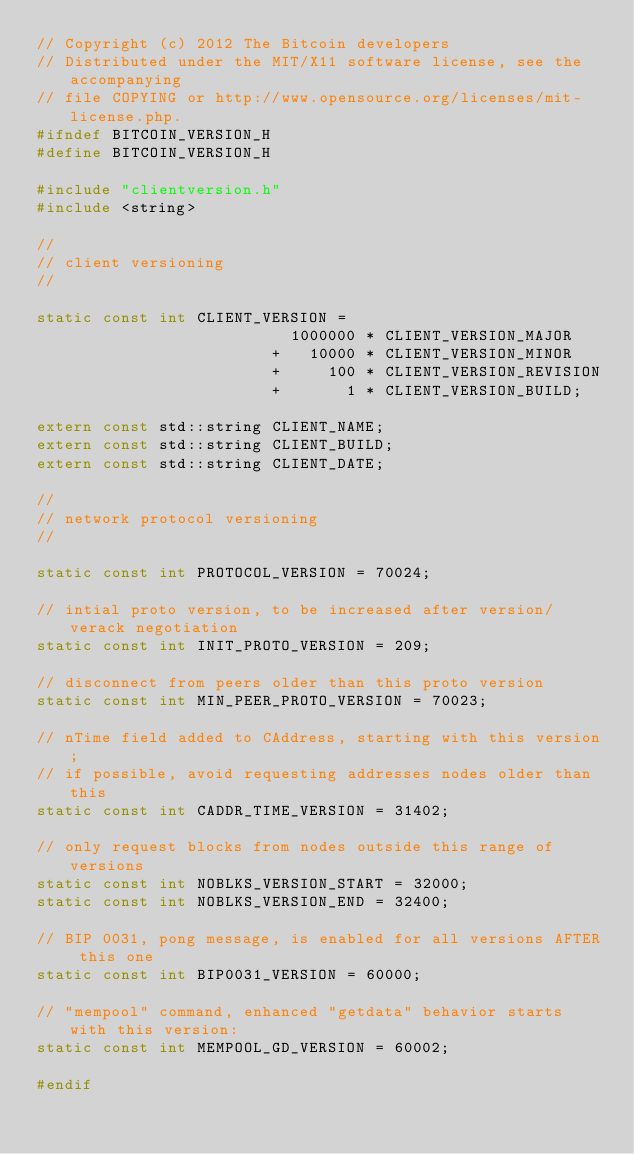Convert code to text. <code><loc_0><loc_0><loc_500><loc_500><_C_>// Copyright (c) 2012 The Bitcoin developers
// Distributed under the MIT/X11 software license, see the accompanying
// file COPYING or http://www.opensource.org/licenses/mit-license.php.
#ifndef BITCOIN_VERSION_H
#define BITCOIN_VERSION_H

#include "clientversion.h"
#include <string>

//
// client versioning
//

static const int CLIENT_VERSION =
                           1000000 * CLIENT_VERSION_MAJOR
                         +   10000 * CLIENT_VERSION_MINOR
                         +     100 * CLIENT_VERSION_REVISION
                         +       1 * CLIENT_VERSION_BUILD;

extern const std::string CLIENT_NAME;
extern const std::string CLIENT_BUILD;
extern const std::string CLIENT_DATE;

//
// network protocol versioning
//

static const int PROTOCOL_VERSION = 70024;

// intial proto version, to be increased after version/verack negotiation
static const int INIT_PROTO_VERSION = 209;

// disconnect from peers older than this proto version
static const int MIN_PEER_PROTO_VERSION = 70023;

// nTime field added to CAddress, starting with this version;
// if possible, avoid requesting addresses nodes older than this
static const int CADDR_TIME_VERSION = 31402;

// only request blocks from nodes outside this range of versions
static const int NOBLKS_VERSION_START = 32000;
static const int NOBLKS_VERSION_END = 32400;

// BIP 0031, pong message, is enabled for all versions AFTER this one
static const int BIP0031_VERSION = 60000;

// "mempool" command, enhanced "getdata" behavior starts with this version:
static const int MEMPOOL_GD_VERSION = 60002;

#endif
</code> 